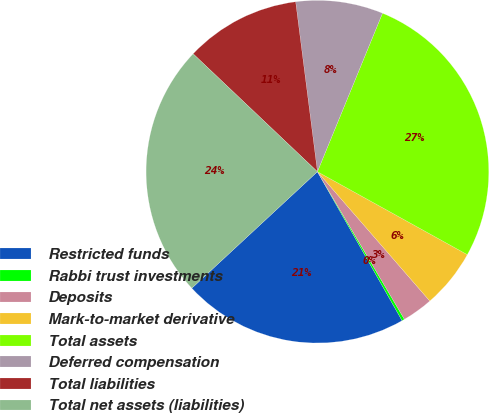Convert chart. <chart><loc_0><loc_0><loc_500><loc_500><pie_chart><fcel>Restricted funds<fcel>Rabbi trust investments<fcel>Deposits<fcel>Mark-to-market derivative<fcel>Total assets<fcel>Deferred compensation<fcel>Total liabilities<fcel>Total net assets (liabilities)<nl><fcel>21.32%<fcel>0.25%<fcel>2.91%<fcel>5.57%<fcel>26.84%<fcel>8.23%<fcel>10.89%<fcel>23.98%<nl></chart> 